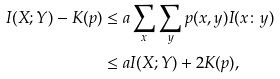<formula> <loc_0><loc_0><loc_500><loc_500>I ( X ; Y ) - K ( p ) & \leq a \sum _ { x } \sum _ { y } p ( x , y ) I ( x \colon y ) \\ & \leq a I ( X ; Y ) + 2 K ( p ) ,</formula> 